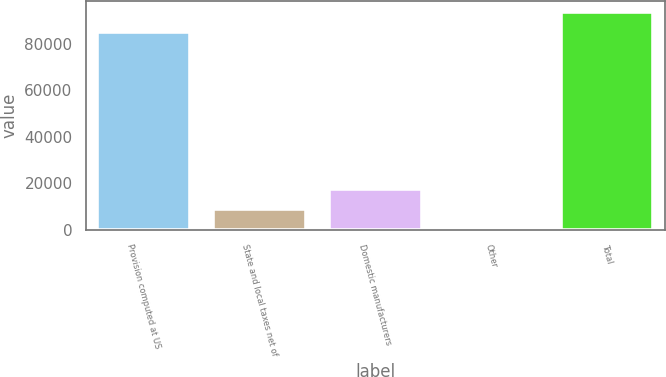Convert chart to OTSL. <chart><loc_0><loc_0><loc_500><loc_500><bar_chart><fcel>Provision computed at US<fcel>State and local taxes net of<fcel>Domestic manufacturers<fcel>Other<fcel>Total<nl><fcel>85226<fcel>8923<fcel>17429<fcel>417<fcel>93732<nl></chart> 